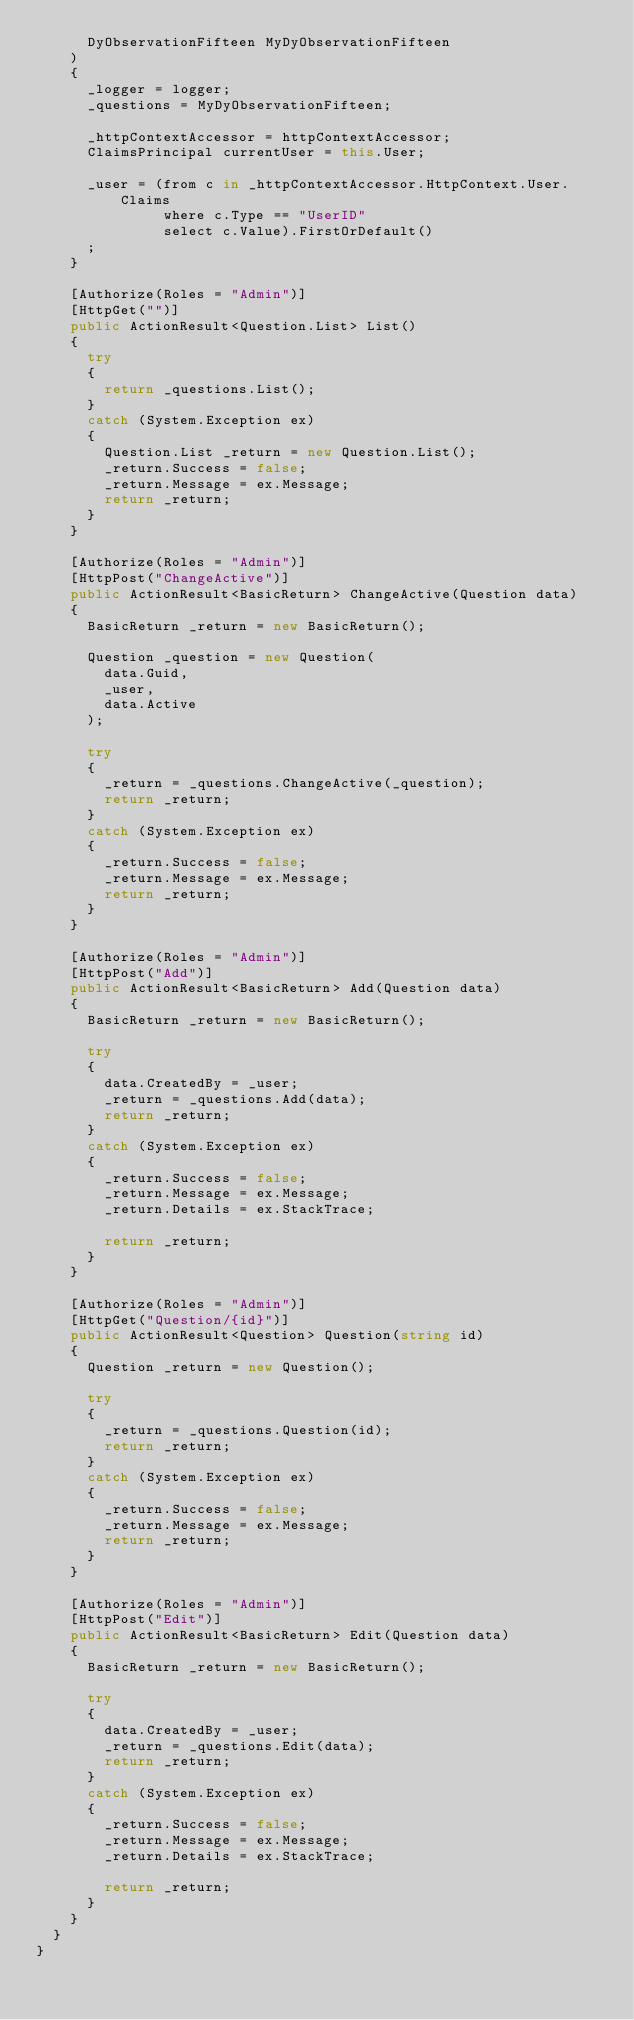<code> <loc_0><loc_0><loc_500><loc_500><_C#_>      DyObservationFifteen MyDyObservationFifteen
    )
    {
      _logger = logger;
      _questions = MyDyObservationFifteen;

      _httpContextAccessor = httpContextAccessor;
      ClaimsPrincipal currentUser = this.User;

      _user = (from c in _httpContextAccessor.HttpContext.User.Claims
               where c.Type == "UserID"
               select c.Value).FirstOrDefault()
      ;
    }

    [Authorize(Roles = "Admin")]
    [HttpGet("")]
    public ActionResult<Question.List> List()
    {
      try
      {
        return _questions.List();
      }
      catch (System.Exception ex)
      {
        Question.List _return = new Question.List();
        _return.Success = false;
        _return.Message = ex.Message;
        return _return;
      }
    }

    [Authorize(Roles = "Admin")]
    [HttpPost("ChangeActive")]
    public ActionResult<BasicReturn> ChangeActive(Question data)
    {
      BasicReturn _return = new BasicReturn();

      Question _question = new Question(
        data.Guid,
        _user,
        data.Active
      );

      try
      {
        _return = _questions.ChangeActive(_question);
        return _return;
      }
      catch (System.Exception ex)
      {
        _return.Success = false;
        _return.Message = ex.Message;
        return _return;
      }
    }

    [Authorize(Roles = "Admin")]
    [HttpPost("Add")]
    public ActionResult<BasicReturn> Add(Question data)
    {
      BasicReturn _return = new BasicReturn();

      try
      {
        data.CreatedBy = _user;
        _return = _questions.Add(data);
        return _return;
      }
      catch (System.Exception ex)
      {
        _return.Success = false;
        _return.Message = ex.Message;
        _return.Details = ex.StackTrace;

        return _return;
      }
    }

    [Authorize(Roles = "Admin")]
    [HttpGet("Question/{id}")]
    public ActionResult<Question> Question(string id)
    {
      Question _return = new Question();
      
      try
      {
        _return = _questions.Question(id);
        return _return;
      }
      catch (System.Exception ex)
      {
        _return.Success = false;
        _return.Message = ex.Message;
        return _return;
      }
    }

    [Authorize(Roles = "Admin")]
    [HttpPost("Edit")]
    public ActionResult<BasicReturn> Edit(Question data)
    {
      BasicReturn _return = new BasicReturn();

      try
      {
        data.CreatedBy = _user;
        _return = _questions.Edit(data);
        return _return;
      }
      catch (System.Exception ex)
      {
        _return.Success = false;
        _return.Message = ex.Message;
        _return.Details = ex.StackTrace;

        return _return;
      }
    }
  }
}</code> 